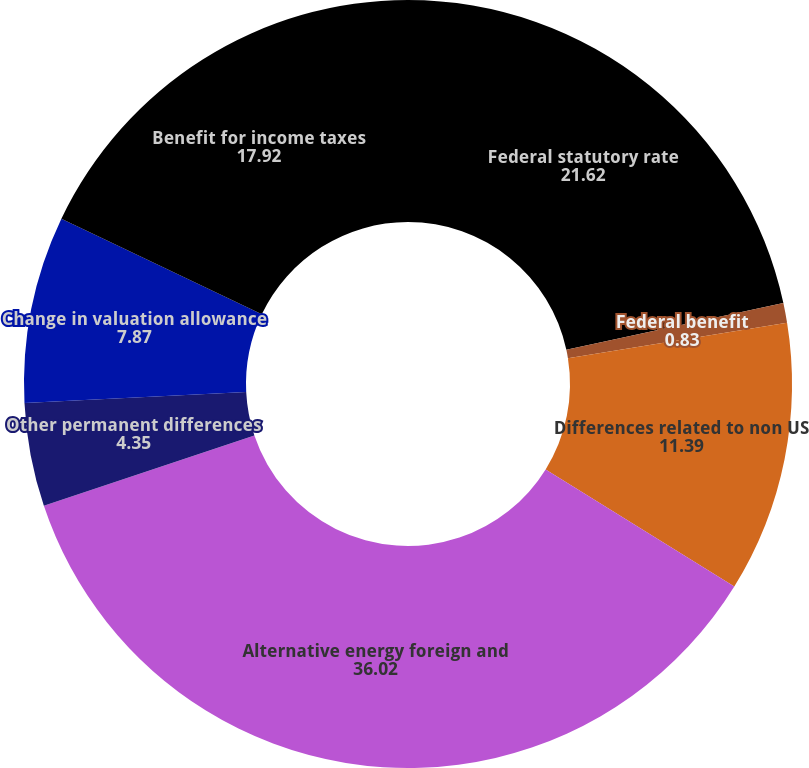Convert chart to OTSL. <chart><loc_0><loc_0><loc_500><loc_500><pie_chart><fcel>Federal statutory rate<fcel>Federal benefit<fcel>Differences related to non US<fcel>Alternative energy foreign and<fcel>Other permanent differences<fcel>Change in valuation allowance<fcel>Benefit for income taxes<nl><fcel>21.62%<fcel>0.83%<fcel>11.39%<fcel>36.02%<fcel>4.35%<fcel>7.87%<fcel>17.92%<nl></chart> 